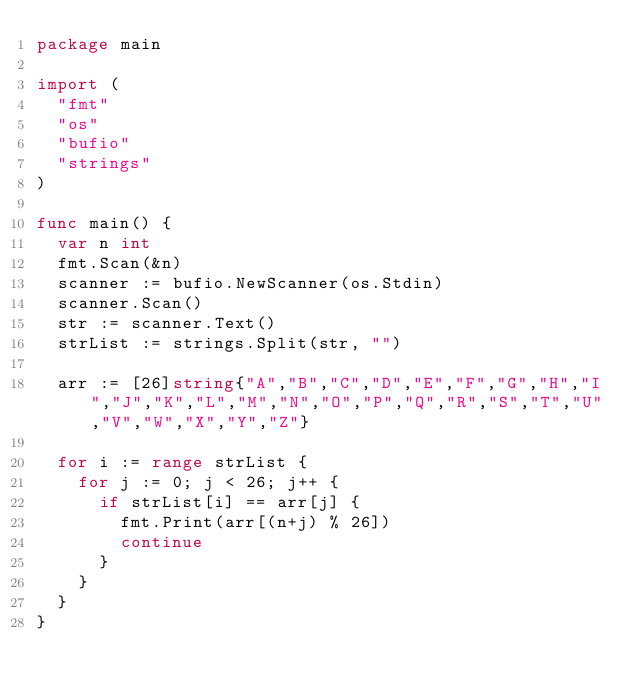Convert code to text. <code><loc_0><loc_0><loc_500><loc_500><_Go_>package main
 
import (
  "fmt"
  "os"
  "bufio"
  "strings"
)
 
func main() {
  var n int
  fmt.Scan(&n)
  scanner := bufio.NewScanner(os.Stdin)
  scanner.Scan()
  str := scanner.Text()
  strList := strings.Split(str, "")
  
  arr := [26]string{"A","B","C","D","E","F","G","H","I","J","K","L","M","N","O","P","Q","R","S","T","U","V","W","X","Y","Z"}
  
  for i := range strList {
    for j := 0; j < 26; j++ {
      if strList[i] == arr[j] {
        fmt.Print(arr[(n+j) % 26])
        continue
      }
    }
  }
}
</code> 